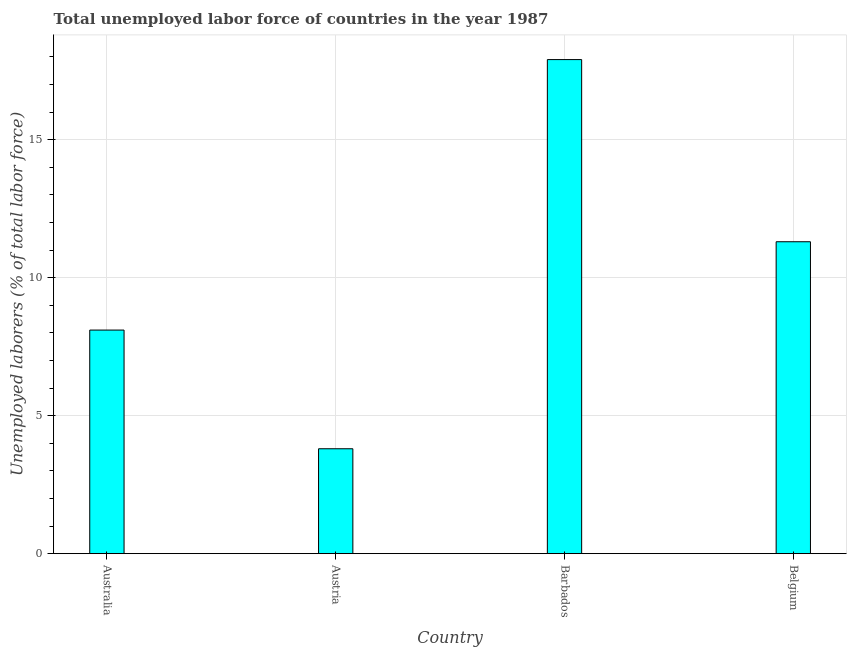Does the graph contain any zero values?
Keep it short and to the point. No. Does the graph contain grids?
Your response must be concise. Yes. What is the title of the graph?
Give a very brief answer. Total unemployed labor force of countries in the year 1987. What is the label or title of the Y-axis?
Offer a very short reply. Unemployed laborers (% of total labor force). What is the total unemployed labour force in Australia?
Give a very brief answer. 8.1. Across all countries, what is the maximum total unemployed labour force?
Make the answer very short. 17.9. Across all countries, what is the minimum total unemployed labour force?
Your answer should be very brief. 3.8. In which country was the total unemployed labour force maximum?
Make the answer very short. Barbados. What is the sum of the total unemployed labour force?
Give a very brief answer. 41.1. What is the difference between the total unemployed labour force in Australia and Barbados?
Ensure brevity in your answer.  -9.8. What is the average total unemployed labour force per country?
Offer a terse response. 10.28. What is the median total unemployed labour force?
Your response must be concise. 9.7. What is the ratio of the total unemployed labour force in Austria to that in Belgium?
Make the answer very short. 0.34. Is the total unemployed labour force in Barbados less than that in Belgium?
Ensure brevity in your answer.  No. Is the sum of the total unemployed labour force in Barbados and Belgium greater than the maximum total unemployed labour force across all countries?
Your response must be concise. Yes. What is the difference between the highest and the lowest total unemployed labour force?
Keep it short and to the point. 14.1. Are the values on the major ticks of Y-axis written in scientific E-notation?
Offer a very short reply. No. What is the Unemployed laborers (% of total labor force) in Australia?
Offer a very short reply. 8.1. What is the Unemployed laborers (% of total labor force) in Austria?
Ensure brevity in your answer.  3.8. What is the Unemployed laborers (% of total labor force) of Barbados?
Give a very brief answer. 17.9. What is the Unemployed laborers (% of total labor force) in Belgium?
Your answer should be very brief. 11.3. What is the difference between the Unemployed laborers (% of total labor force) in Australia and Belgium?
Provide a succinct answer. -3.2. What is the difference between the Unemployed laborers (% of total labor force) in Austria and Barbados?
Offer a very short reply. -14.1. What is the difference between the Unemployed laborers (% of total labor force) in Barbados and Belgium?
Ensure brevity in your answer.  6.6. What is the ratio of the Unemployed laborers (% of total labor force) in Australia to that in Austria?
Provide a short and direct response. 2.13. What is the ratio of the Unemployed laborers (% of total labor force) in Australia to that in Barbados?
Your answer should be very brief. 0.45. What is the ratio of the Unemployed laborers (% of total labor force) in Australia to that in Belgium?
Make the answer very short. 0.72. What is the ratio of the Unemployed laborers (% of total labor force) in Austria to that in Barbados?
Offer a very short reply. 0.21. What is the ratio of the Unemployed laborers (% of total labor force) in Austria to that in Belgium?
Offer a very short reply. 0.34. What is the ratio of the Unemployed laborers (% of total labor force) in Barbados to that in Belgium?
Your answer should be very brief. 1.58. 